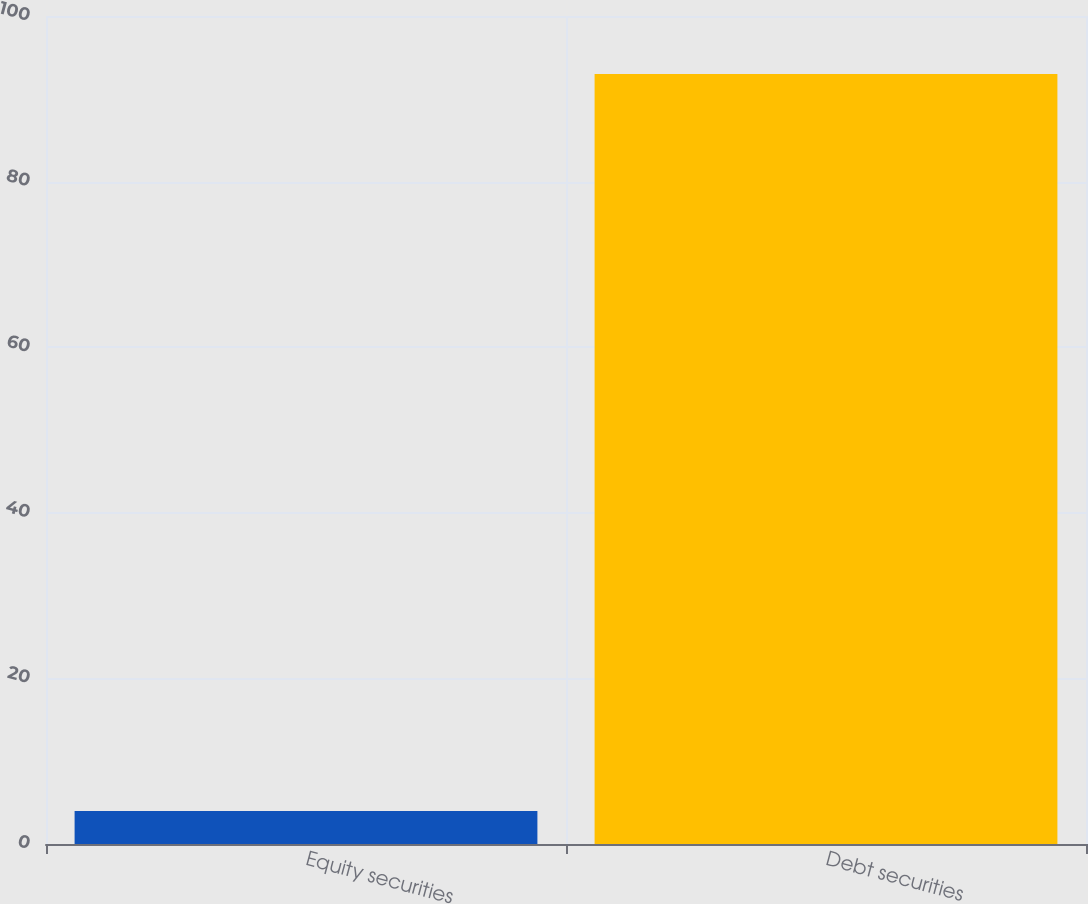Convert chart. <chart><loc_0><loc_0><loc_500><loc_500><bar_chart><fcel>Equity securities<fcel>Debt securities<nl><fcel>4<fcel>93<nl></chart> 